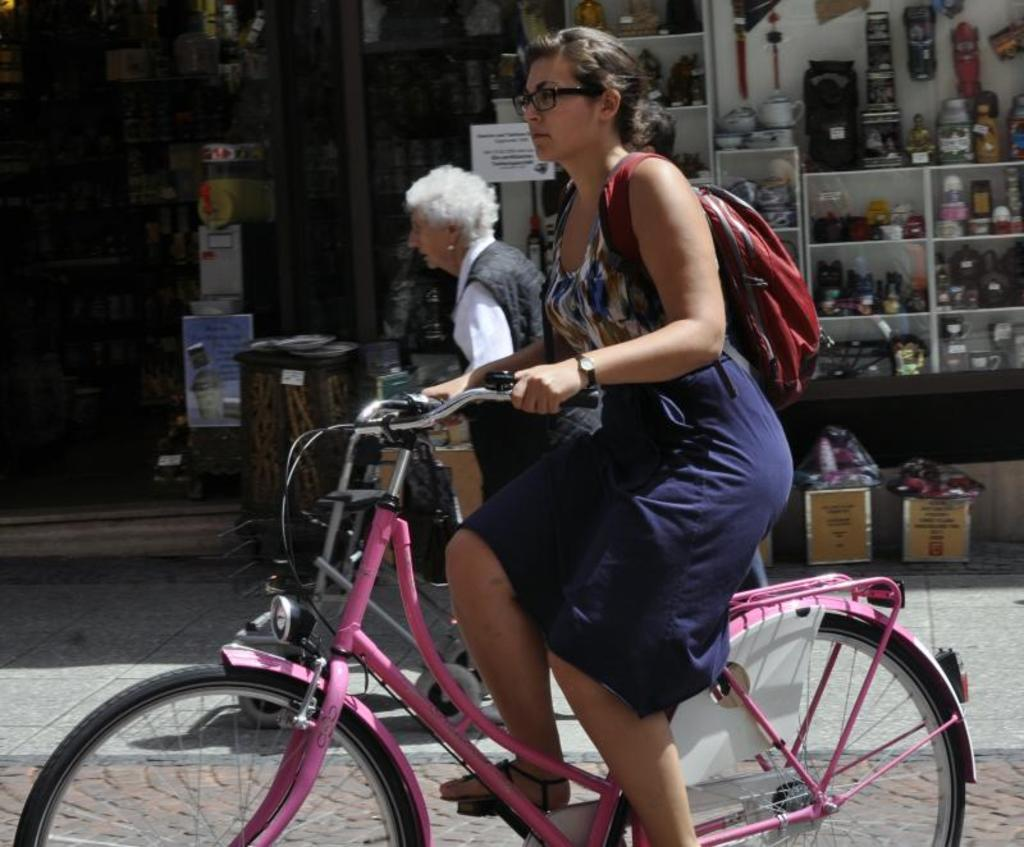How many people are in the image? There are two people in the image. What is one person doing in the image? One person is riding a bicycle. What can be seen at the right side of the image? There is a shop at the right side of the image. How much money is being exchanged at the airport in the image? There is no airport present in the image, and therefore no money exchange can be observed. What type of salt is being used to season the food in the image? There is no food or salt present in the image. 